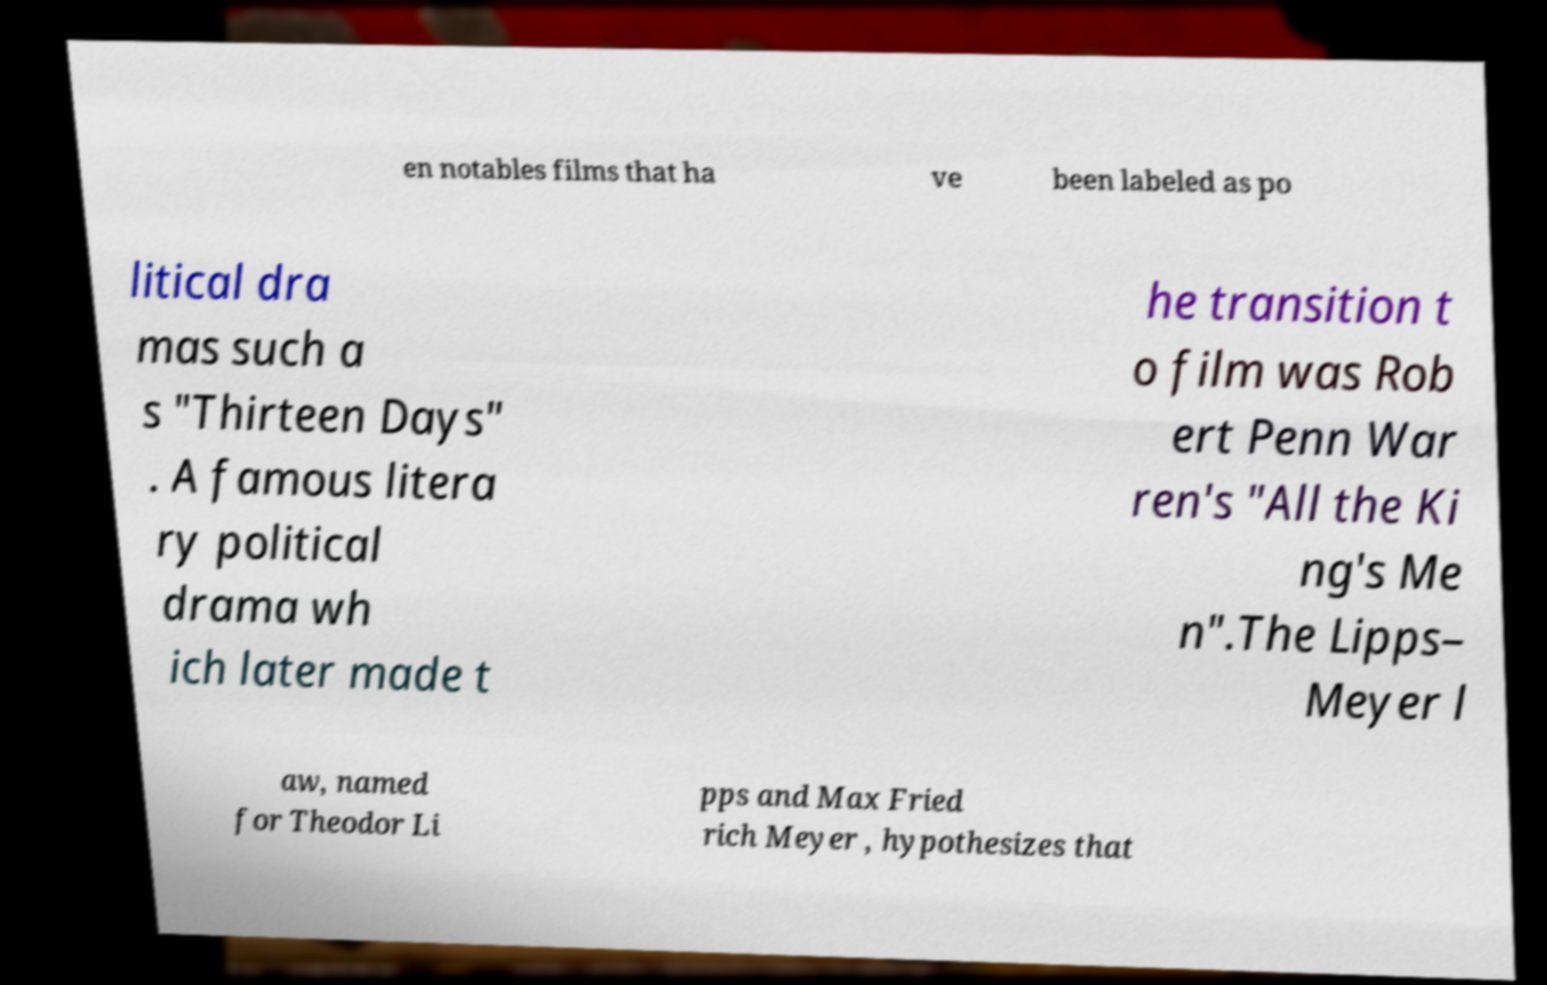What messages or text are displayed in this image? I need them in a readable, typed format. en notables films that ha ve been labeled as po litical dra mas such a s "Thirteen Days" . A famous litera ry political drama wh ich later made t he transition t o film was Rob ert Penn War ren's "All the Ki ng's Me n".The Lipps– Meyer l aw, named for Theodor Li pps and Max Fried rich Meyer , hypothesizes that 